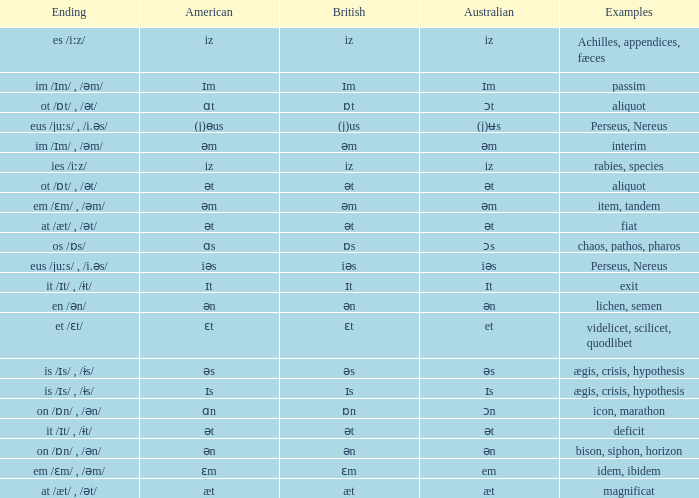Which American has British of ɛm? Ɛm. 